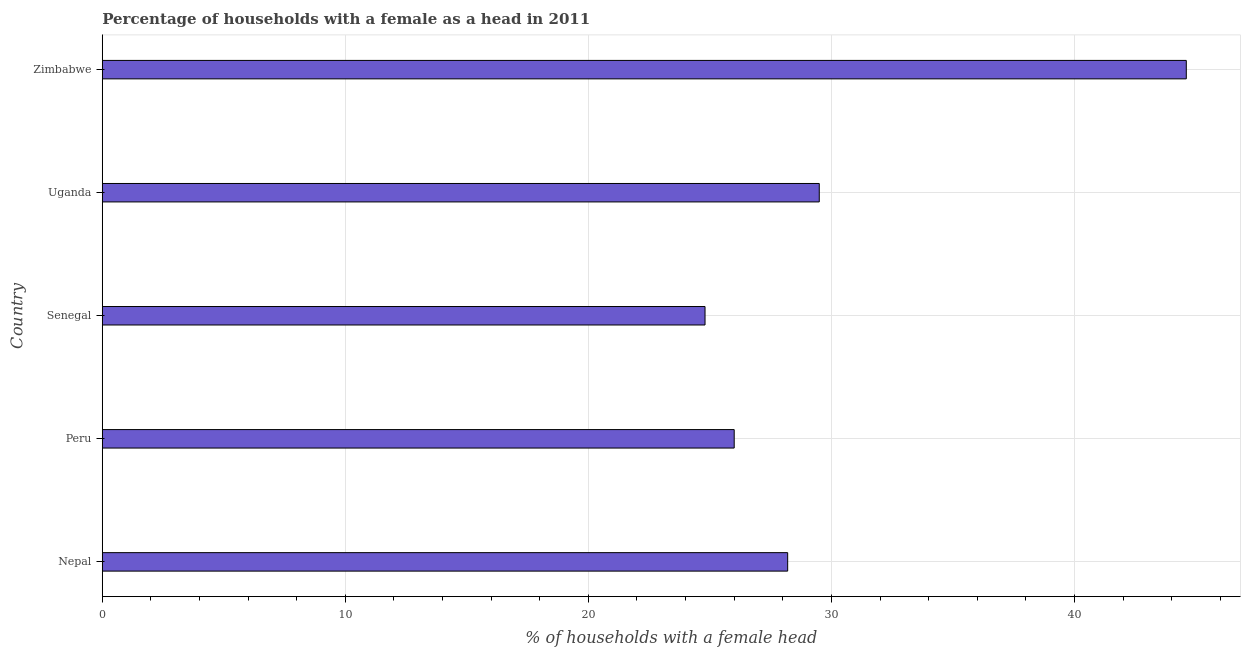What is the title of the graph?
Provide a succinct answer. Percentage of households with a female as a head in 2011. What is the label or title of the X-axis?
Offer a very short reply. % of households with a female head. What is the number of female supervised households in Uganda?
Your answer should be very brief. 29.5. Across all countries, what is the maximum number of female supervised households?
Make the answer very short. 44.6. Across all countries, what is the minimum number of female supervised households?
Make the answer very short. 24.8. In which country was the number of female supervised households maximum?
Offer a very short reply. Zimbabwe. In which country was the number of female supervised households minimum?
Your answer should be very brief. Senegal. What is the sum of the number of female supervised households?
Provide a short and direct response. 153.1. What is the average number of female supervised households per country?
Provide a short and direct response. 30.62. What is the median number of female supervised households?
Your answer should be compact. 28.2. What is the ratio of the number of female supervised households in Nepal to that in Senegal?
Your answer should be very brief. 1.14. What is the difference between the highest and the second highest number of female supervised households?
Provide a succinct answer. 15.1. Is the sum of the number of female supervised households in Nepal and Senegal greater than the maximum number of female supervised households across all countries?
Keep it short and to the point. Yes. What is the difference between the highest and the lowest number of female supervised households?
Ensure brevity in your answer.  19.8. How many bars are there?
Your answer should be compact. 5. Are all the bars in the graph horizontal?
Provide a succinct answer. Yes. How many countries are there in the graph?
Your answer should be very brief. 5. What is the % of households with a female head in Nepal?
Ensure brevity in your answer.  28.2. What is the % of households with a female head of Senegal?
Provide a succinct answer. 24.8. What is the % of households with a female head of Uganda?
Ensure brevity in your answer.  29.5. What is the % of households with a female head in Zimbabwe?
Your answer should be compact. 44.6. What is the difference between the % of households with a female head in Nepal and Peru?
Your response must be concise. 2.2. What is the difference between the % of households with a female head in Nepal and Zimbabwe?
Your response must be concise. -16.4. What is the difference between the % of households with a female head in Peru and Senegal?
Offer a terse response. 1.2. What is the difference between the % of households with a female head in Peru and Zimbabwe?
Your answer should be compact. -18.6. What is the difference between the % of households with a female head in Senegal and Uganda?
Make the answer very short. -4.7. What is the difference between the % of households with a female head in Senegal and Zimbabwe?
Offer a very short reply. -19.8. What is the difference between the % of households with a female head in Uganda and Zimbabwe?
Your answer should be compact. -15.1. What is the ratio of the % of households with a female head in Nepal to that in Peru?
Your response must be concise. 1.08. What is the ratio of the % of households with a female head in Nepal to that in Senegal?
Give a very brief answer. 1.14. What is the ratio of the % of households with a female head in Nepal to that in Uganda?
Provide a short and direct response. 0.96. What is the ratio of the % of households with a female head in Nepal to that in Zimbabwe?
Keep it short and to the point. 0.63. What is the ratio of the % of households with a female head in Peru to that in Senegal?
Give a very brief answer. 1.05. What is the ratio of the % of households with a female head in Peru to that in Uganda?
Offer a terse response. 0.88. What is the ratio of the % of households with a female head in Peru to that in Zimbabwe?
Your response must be concise. 0.58. What is the ratio of the % of households with a female head in Senegal to that in Uganda?
Ensure brevity in your answer.  0.84. What is the ratio of the % of households with a female head in Senegal to that in Zimbabwe?
Your response must be concise. 0.56. What is the ratio of the % of households with a female head in Uganda to that in Zimbabwe?
Provide a short and direct response. 0.66. 